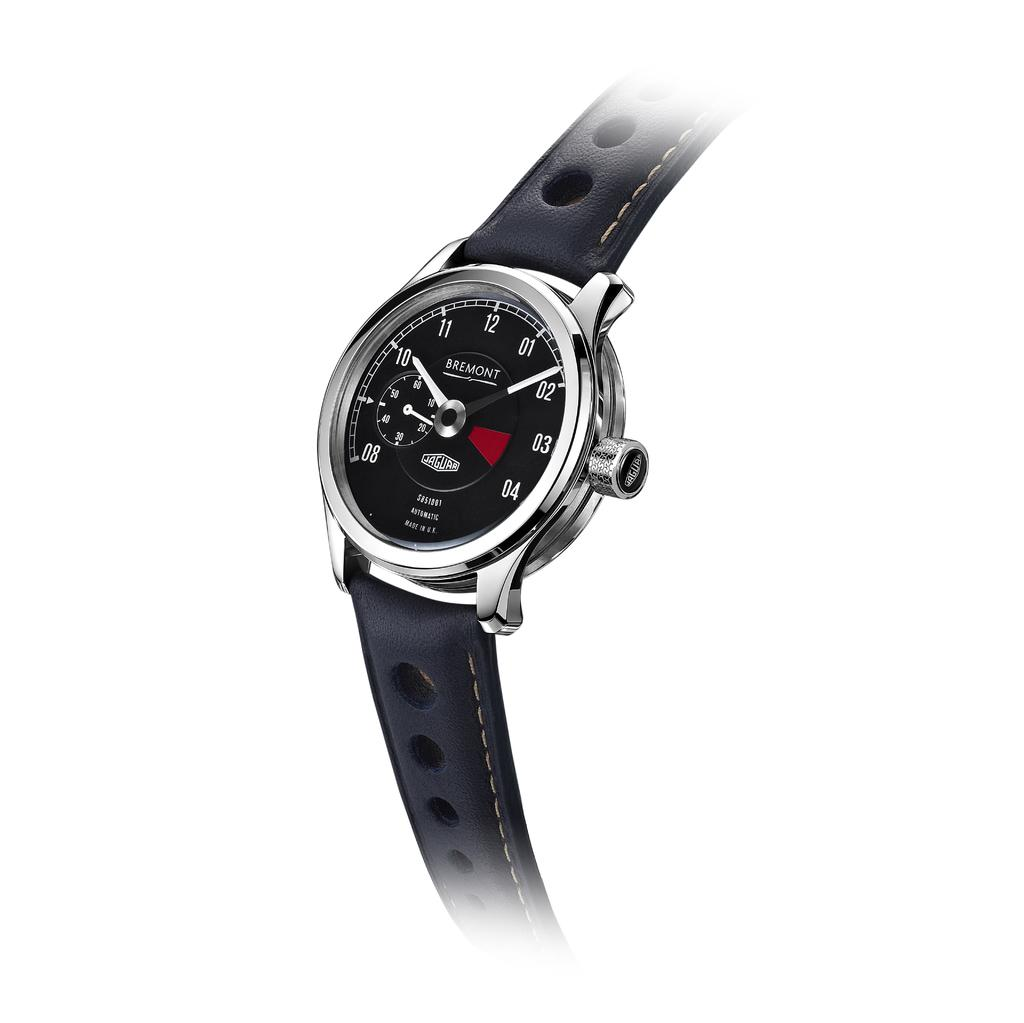<image>
Present a compact description of the photo's key features. A Bremont Jaguar watch set against a white background 